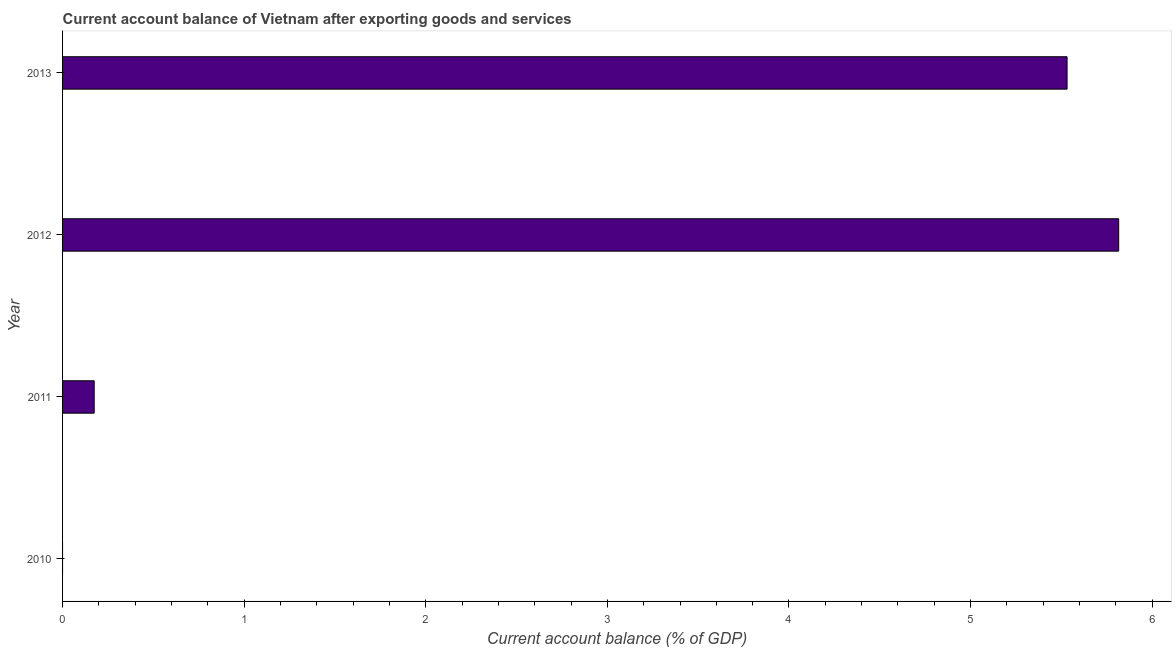What is the title of the graph?
Your answer should be very brief. Current account balance of Vietnam after exporting goods and services. What is the label or title of the X-axis?
Ensure brevity in your answer.  Current account balance (% of GDP). What is the label or title of the Y-axis?
Keep it short and to the point. Year. What is the current account balance in 2012?
Offer a terse response. 5.82. Across all years, what is the maximum current account balance?
Offer a terse response. 5.82. What is the sum of the current account balance?
Offer a very short reply. 11.52. What is the difference between the current account balance in 2011 and 2012?
Ensure brevity in your answer.  -5.64. What is the average current account balance per year?
Make the answer very short. 2.88. What is the median current account balance?
Your response must be concise. 2.85. What is the ratio of the current account balance in 2012 to that in 2013?
Ensure brevity in your answer.  1.05. Is the current account balance in 2012 less than that in 2013?
Ensure brevity in your answer.  No. Is the difference between the current account balance in 2012 and 2013 greater than the difference between any two years?
Your answer should be very brief. No. What is the difference between the highest and the second highest current account balance?
Your answer should be very brief. 0.28. What is the difference between the highest and the lowest current account balance?
Provide a succinct answer. 5.82. In how many years, is the current account balance greater than the average current account balance taken over all years?
Give a very brief answer. 2. How many years are there in the graph?
Provide a short and direct response. 4. What is the difference between two consecutive major ticks on the X-axis?
Ensure brevity in your answer.  1. Are the values on the major ticks of X-axis written in scientific E-notation?
Your answer should be compact. No. What is the Current account balance (% of GDP) of 2011?
Make the answer very short. 0.17. What is the Current account balance (% of GDP) in 2012?
Your answer should be compact. 5.82. What is the Current account balance (% of GDP) of 2013?
Make the answer very short. 5.53. What is the difference between the Current account balance (% of GDP) in 2011 and 2012?
Offer a very short reply. -5.64. What is the difference between the Current account balance (% of GDP) in 2011 and 2013?
Make the answer very short. -5.36. What is the difference between the Current account balance (% of GDP) in 2012 and 2013?
Give a very brief answer. 0.28. What is the ratio of the Current account balance (% of GDP) in 2011 to that in 2013?
Offer a terse response. 0.03. What is the ratio of the Current account balance (% of GDP) in 2012 to that in 2013?
Your answer should be very brief. 1.05. 